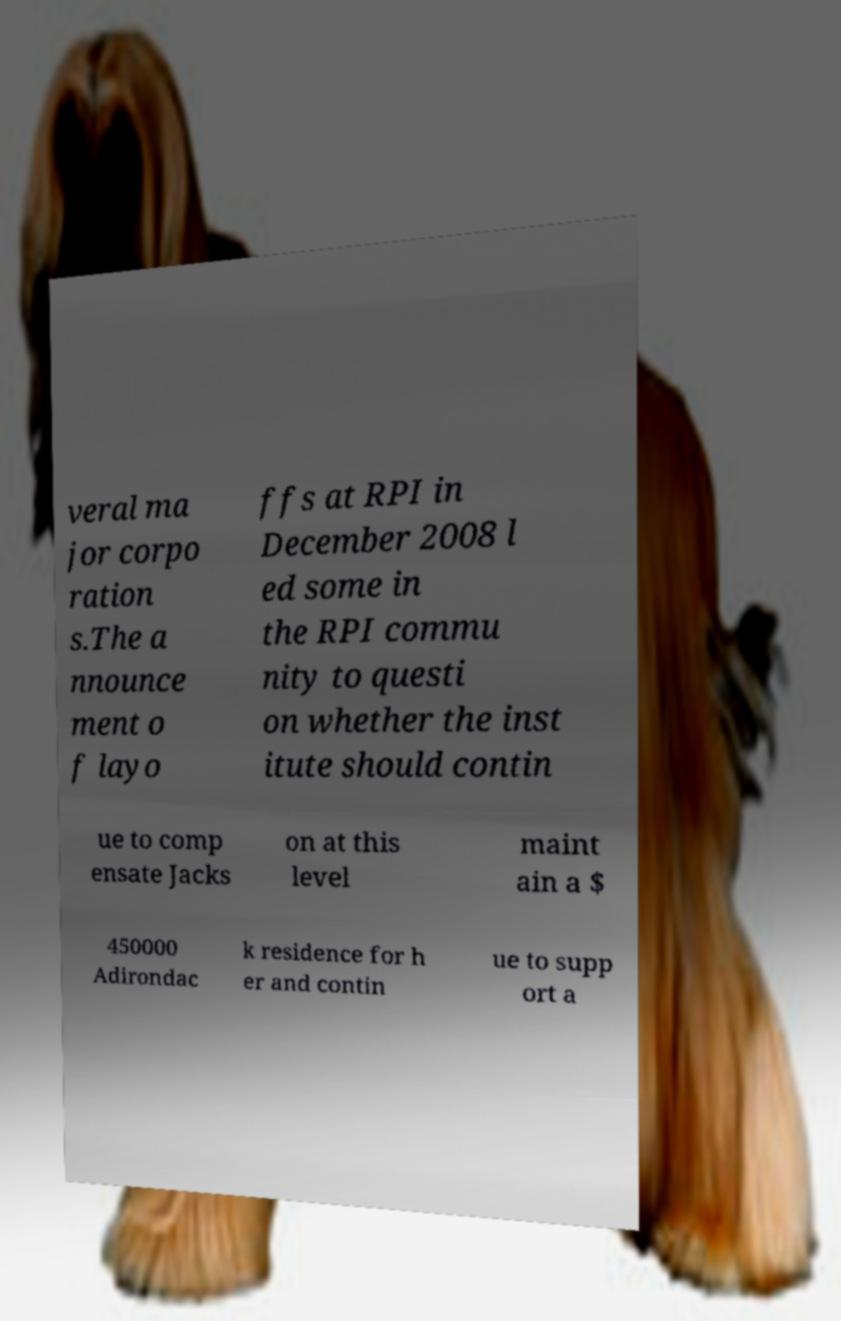Can you read and provide the text displayed in the image?This photo seems to have some interesting text. Can you extract and type it out for me? veral ma jor corpo ration s.The a nnounce ment o f layo ffs at RPI in December 2008 l ed some in the RPI commu nity to questi on whether the inst itute should contin ue to comp ensate Jacks on at this level maint ain a $ 450000 Adirondac k residence for h er and contin ue to supp ort a 